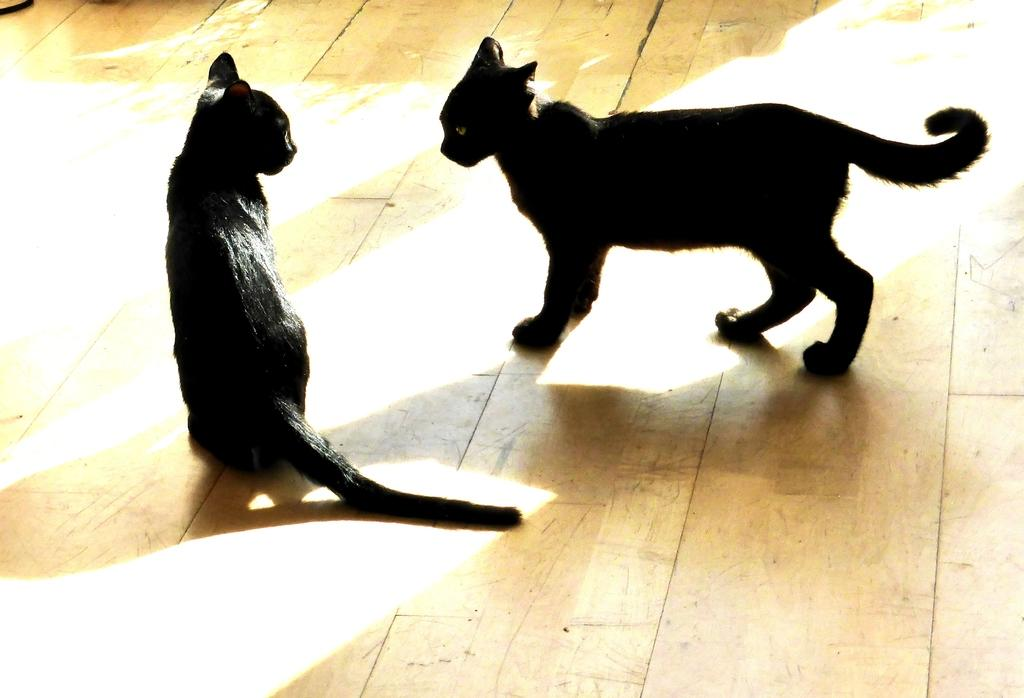How many cats are in the image? There are two black cats in the image. What is the surface on which the cats are standing? The cats are on a wooden floor. What is the position of the first cat? One cat is sitting. What is the position of the second cat? The other cat is standing. What type of flower can be seen blooming in the image? There are no flowers present in the image; it features two black cats on a wooden floor. 